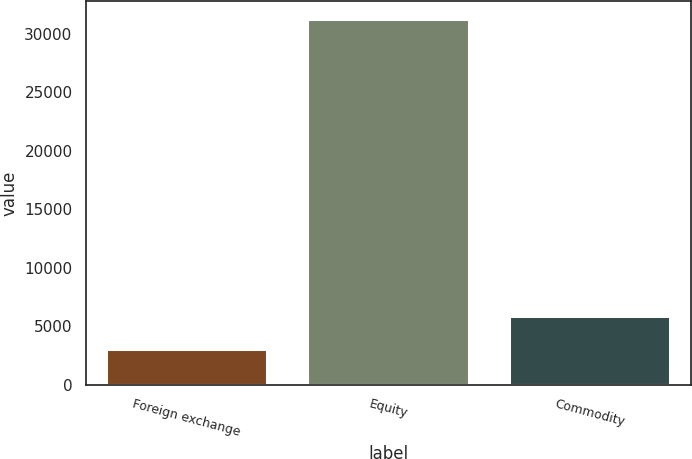Convert chart to OTSL. <chart><loc_0><loc_0><loc_500><loc_500><bar_chart><fcel>Foreign exchange<fcel>Equity<fcel>Commodity<nl><fcel>3026<fcel>31235<fcel>5846.9<nl></chart> 